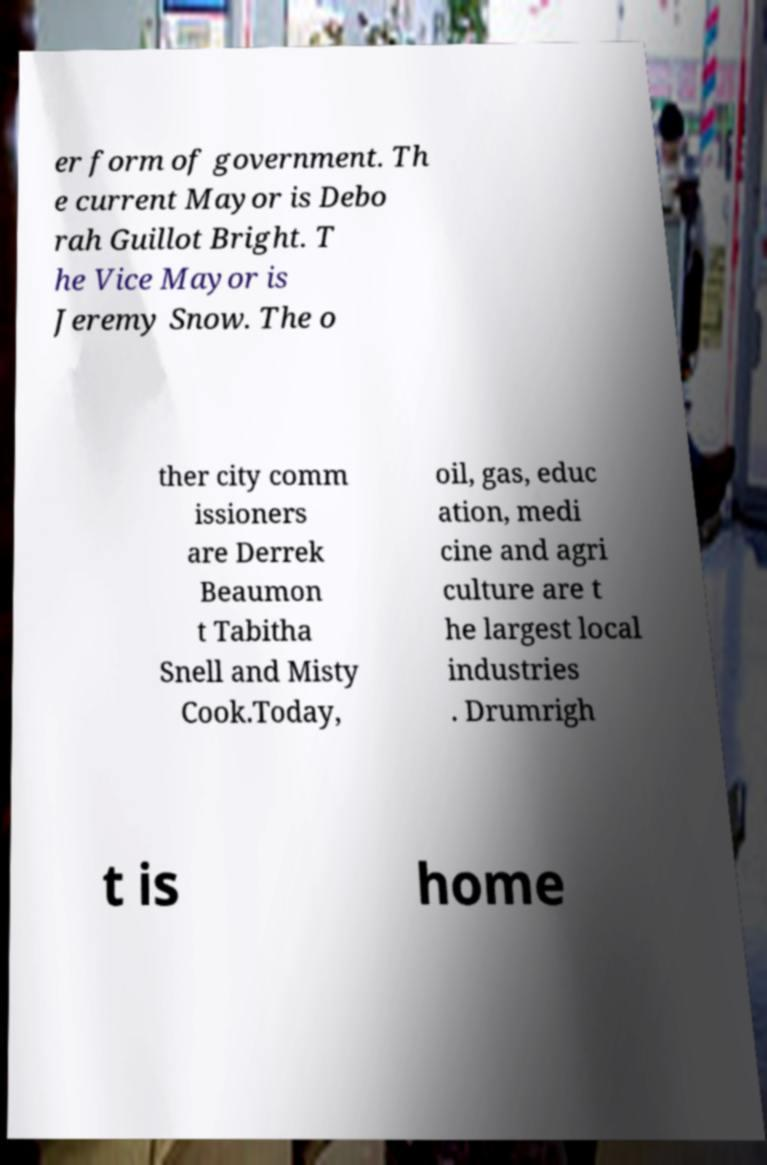I need the written content from this picture converted into text. Can you do that? er form of government. Th e current Mayor is Debo rah Guillot Bright. T he Vice Mayor is Jeremy Snow. The o ther city comm issioners are Derrek Beaumon t Tabitha Snell and Misty Cook.Today, oil, gas, educ ation, medi cine and agri culture are t he largest local industries . Drumrigh t is home 